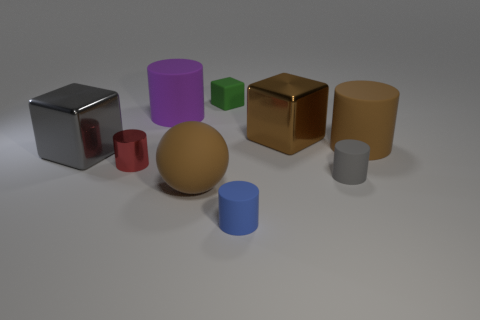What is the material of the gray cube?
Your answer should be very brief. Metal. Is the number of blue objects that are behind the rubber block greater than the number of small brown spheres?
Make the answer very short. No. Are there any large brown shiny things?
Ensure brevity in your answer.  Yes. What number of other things are there of the same shape as the tiny gray rubber object?
Your answer should be very brief. 4. There is a cube on the left side of the ball; does it have the same color as the rubber thing right of the gray rubber cylinder?
Keep it short and to the point. No. There is a brown matte object that is left of the gray thing that is to the right of the large shiny cube that is behind the gray shiny thing; how big is it?
Offer a terse response. Large. What is the shape of the thing that is both to the left of the matte sphere and on the right side of the shiny cylinder?
Make the answer very short. Cylinder. Are there an equal number of large purple matte things that are behind the purple cylinder and balls that are on the right side of the matte ball?
Offer a terse response. Yes. Is there a large yellow block made of the same material as the tiny green thing?
Ensure brevity in your answer.  No. Is the material of the gray object that is to the right of the small red metallic cylinder the same as the big gray object?
Give a very brief answer. No. 